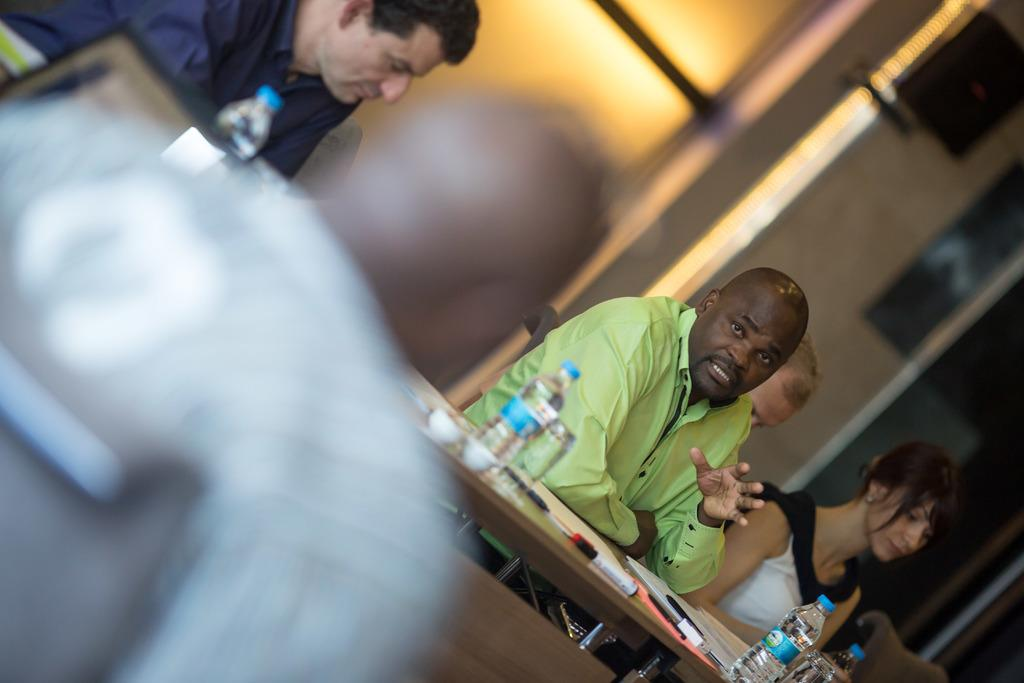What are the persons in the image doing? The persons in the image are sitting on chairs. What is present on the table in the image? There are bottles, glasses, cups, and papers on the table. What is the background of the image? There is a wall in the background of the image. What type of leather is visible on the table in the image? There is no leather present on the table in the image. What attraction can be seen in the background of the image? There is no attraction visible in the background of the image; it only shows a wall. 